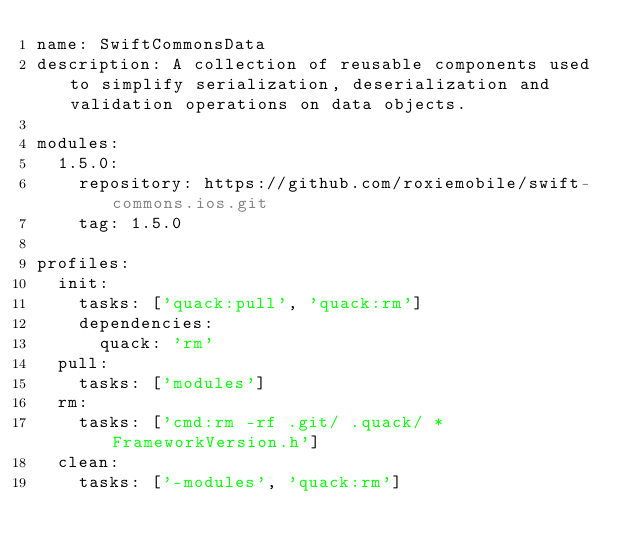<code> <loc_0><loc_0><loc_500><loc_500><_YAML_>name: SwiftCommonsData
description: A collection of reusable components used to simplify serialization, deserialization and validation operations on data objects.

modules:
  1.5.0:
    repository: https://github.com/roxiemobile/swift-commons.ios.git
    tag: 1.5.0

profiles:
  init:
    tasks: ['quack:pull', 'quack:rm']
    dependencies:
      quack: 'rm'
  pull:
    tasks: ['modules']
  rm:
    tasks: ['cmd:rm -rf .git/ .quack/ *FrameworkVersion.h']
  clean:
    tasks: ['-modules', 'quack:rm']
</code> 